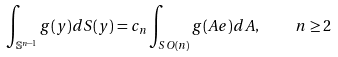Convert formula to latex. <formula><loc_0><loc_0><loc_500><loc_500>\int _ { \mathbb { S } ^ { n - 1 } } g ( y ) d S ( y ) = c _ { n } \int _ { S O ( n ) } g ( A e ) d A , \quad n \geq 2</formula> 